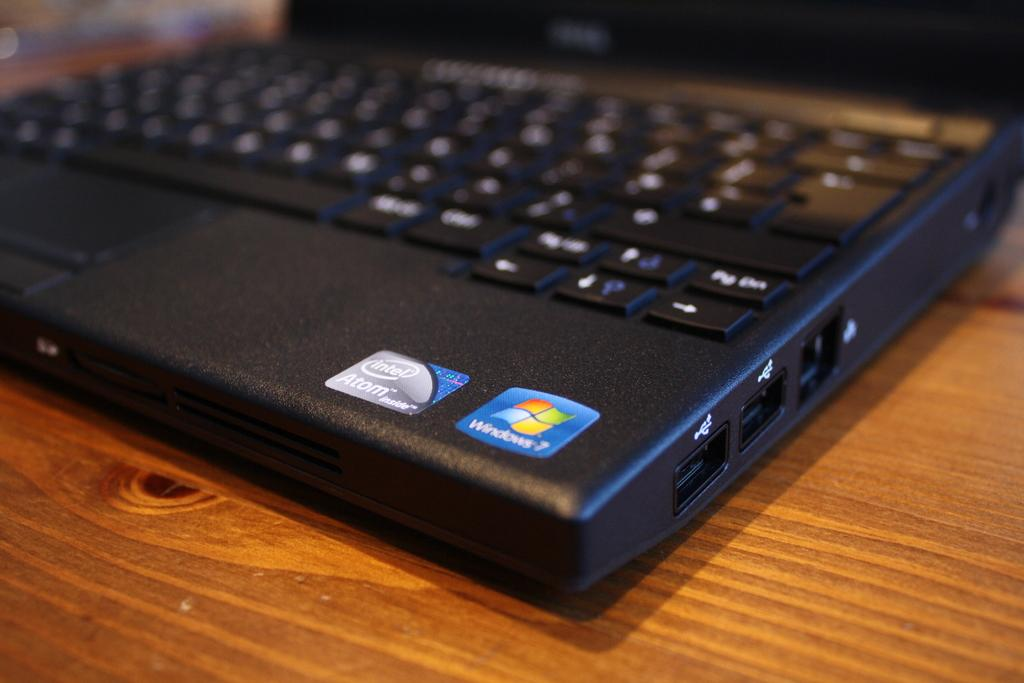<image>
Summarize the visual content of the image. A black laptop has a colorful sticker that has a logo for Windows. 